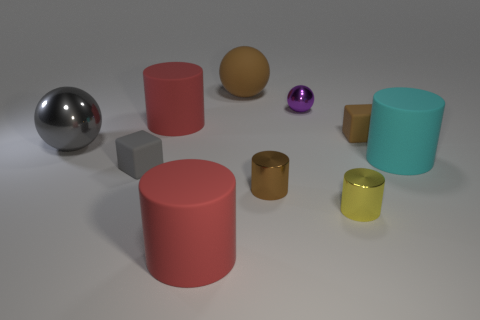Subtract all big cyan cylinders. How many cylinders are left? 4 Subtract all yellow cylinders. How many cylinders are left? 4 Subtract all cyan cylinders. Subtract all blue spheres. How many cylinders are left? 4 Subtract all cubes. How many objects are left? 8 Add 2 large cyan spheres. How many large cyan spheres exist? 2 Subtract 0 yellow blocks. How many objects are left? 10 Subtract all yellow cylinders. Subtract all small gray objects. How many objects are left? 8 Add 7 large cylinders. How many large cylinders are left? 10 